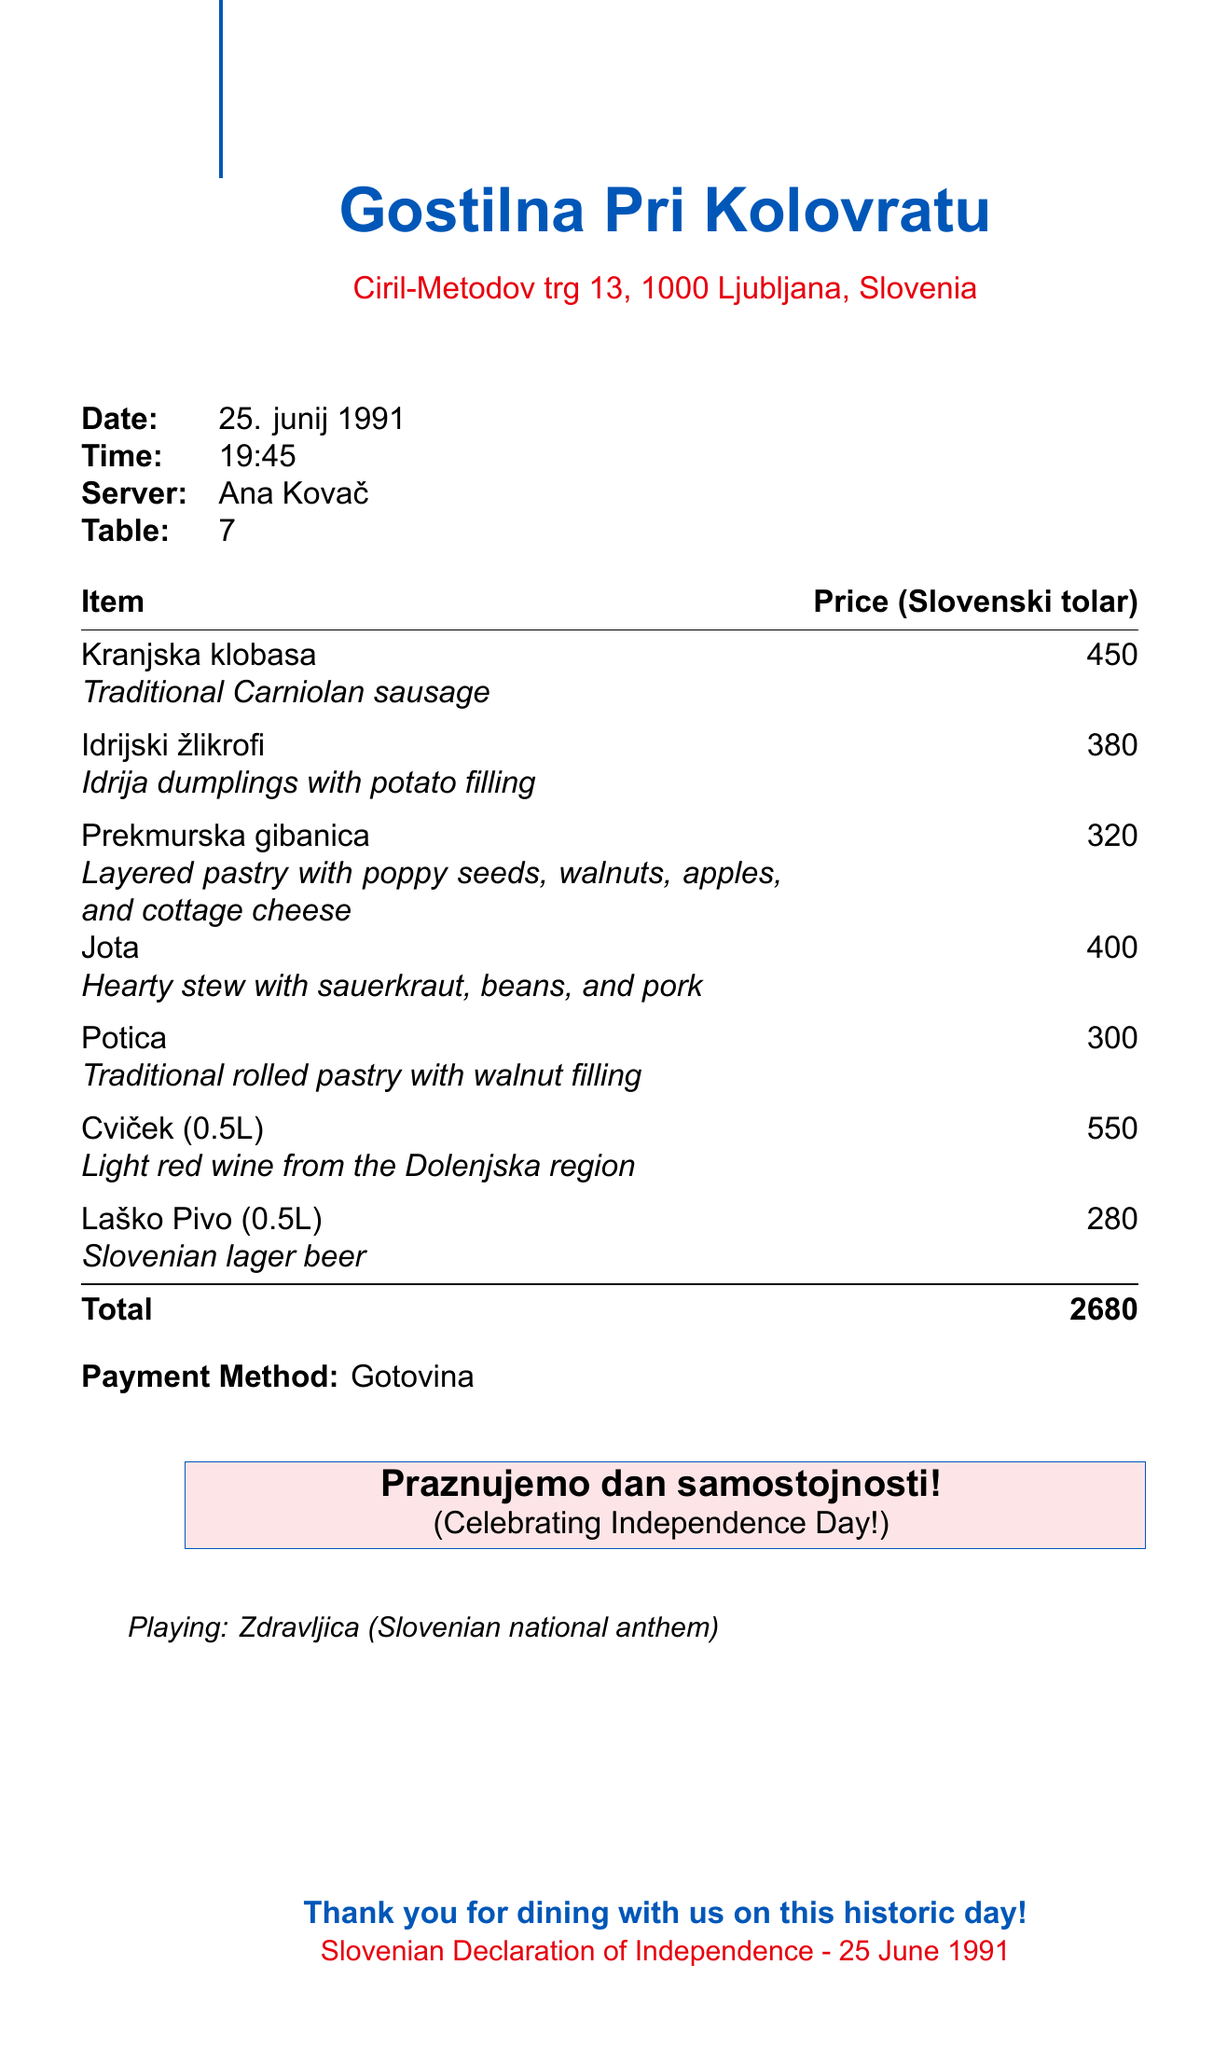What is the name of the restaurant? The name of the restaurant is provided in the document as "Gostilna Pri Kolovratu."
Answer: Gostilna Pri Kolovratu What is the total amount of the receipt? The total amount is explicitly stated in the document as "2680 Slovenski tolar."
Answer: 2680 Who was the server for this table? The server's name is listed on the receipt as "Ana Kovač."
Answer: Ana Kovač What dish is described as a hearty stew? The dish described as a hearty stew is "Jota."
Answer: Jota What significant event is celebrated on the date of the receipt? The significant event celebrated is the "Slovenian Declaration of Independence."
Answer: Slovenian Declaration of Independence How much does a Kranjska klobasa cost? The price of Kranjska klobasa is detailed in the document as "450 Slovenski tolar."
Answer: 450 What type of wine is mentioned in the items? The type of wine mentioned is "Cviček."
Answer: Cviček What is the payment method used for this meal? The payment method is specified as "Gotovina."
Answer: Gotovina What music was playing during the dinner? The music playing, as noted in the document, is "Zdravljica."
Answer: Zdravljica 